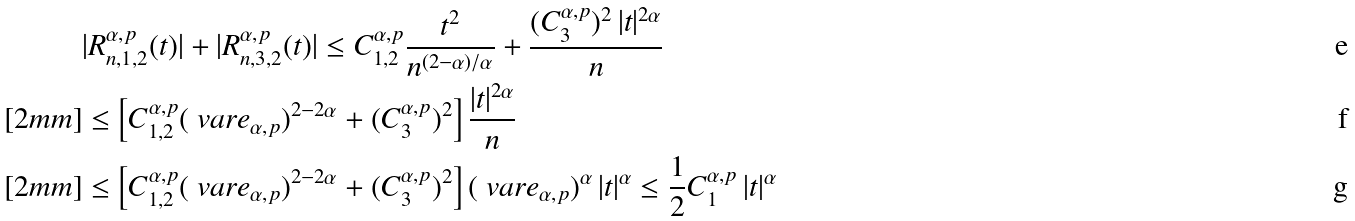<formula> <loc_0><loc_0><loc_500><loc_500>& | R _ { n , 1 , 2 } ^ { \alpha , p } ( t ) | + | R _ { n , 3 , 2 } ^ { \alpha , p } ( t ) | \leq C _ { 1 , 2 } ^ { \alpha , p } \frac { t ^ { 2 } } { n ^ { ( 2 - \alpha ) / \alpha } } + \frac { ( C _ { 3 } ^ { \alpha , p } ) ^ { 2 } \, | t | ^ { 2 \alpha } } { n } \\ [ 2 m m ] & \leq \left [ C _ { 1 , 2 } ^ { \alpha , p } ( \ v a r e _ { \alpha , p } ) ^ { 2 - 2 \alpha } + ( C _ { 3 } ^ { \alpha , p } ) ^ { 2 } \right ] \frac { | t | ^ { 2 \alpha } } { n } \\ [ 2 m m ] & \leq \left [ C _ { 1 , 2 } ^ { \alpha , p } ( \ v a r e _ { \alpha , p } ) ^ { 2 - 2 \alpha } + ( C _ { 3 } ^ { \alpha , p } ) ^ { 2 } \right ] ( \ v a r e _ { \alpha , p } ) ^ { \alpha } \, | t | ^ { \alpha } \leq \frac { 1 } { 2 } C _ { 1 } ^ { \alpha , p } \, | t | ^ { \alpha }</formula> 